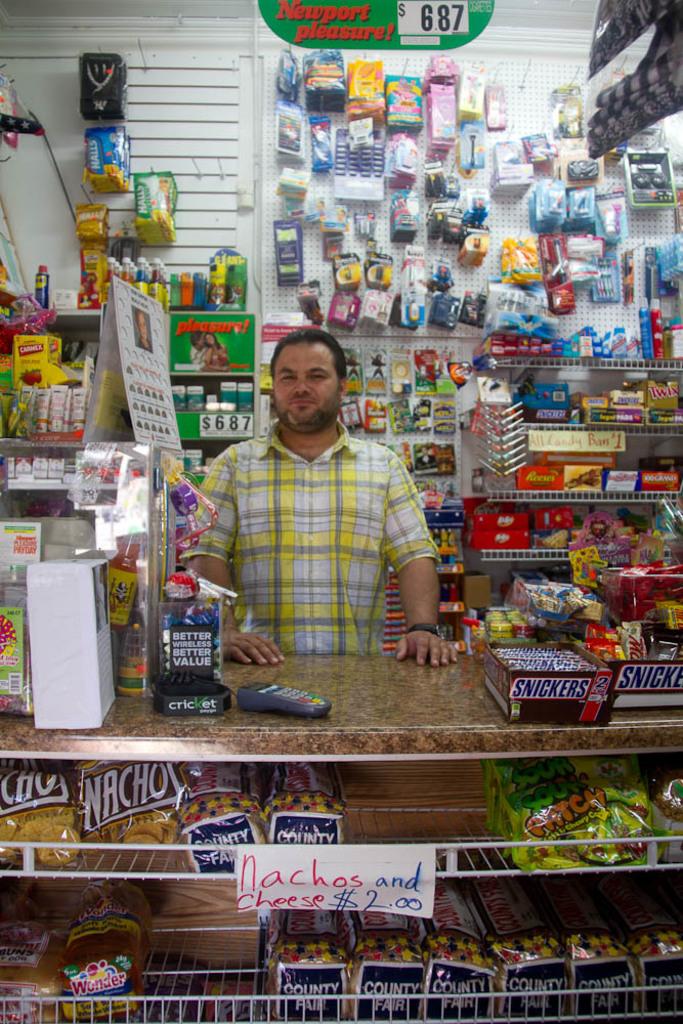What is the cost for nachos?
Your answer should be compact. $2.00. How much are newports?
Offer a very short reply. $6.87. 